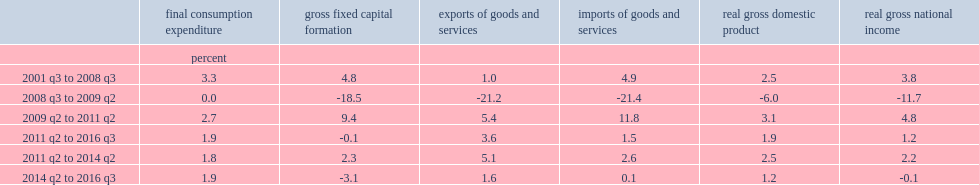Could you parse the entire table as a dict? {'header': ['', 'final consumption expenditure', 'gross fixed capital formation', 'exports of goods and services', 'imports of goods and services', 'real gross domestic product', 'real gross national income'], 'rows': [['', 'percent', '', '', '', '', ''], ['2001 q3 to 2008 q3', '3.3', '4.8', '1.0', '4.9', '2.5', '3.8'], ['2008 q3 to 2009 q2', '0.0', '-18.5', '-21.2', '-21.4', '-6.0', '-11.7'], ['2009 q2 to 2011 q2', '2.7', '9.4', '5.4', '11.8', '3.1', '4.8'], ['2011 q2 to 2016 q3', '1.9', '-0.1', '3.6', '1.5', '1.9', '1.2'], ['2011 q2 to 2014 q2', '1.8', '2.3', '5.1', '2.6', '2.5', '2.2'], ['2014 q2 to 2016 q3', '1.9', '-3.1', '1.6', '0.1', '1.2', '-0.1']]} During the 2008-2009 recession,which did changes in components of real gdp typically exhibit growth rate patterns more,real gni or real gdp? Real gross national income. During the 2008-2009 recession,what percentage points did real gfcf changed? -18.5. 